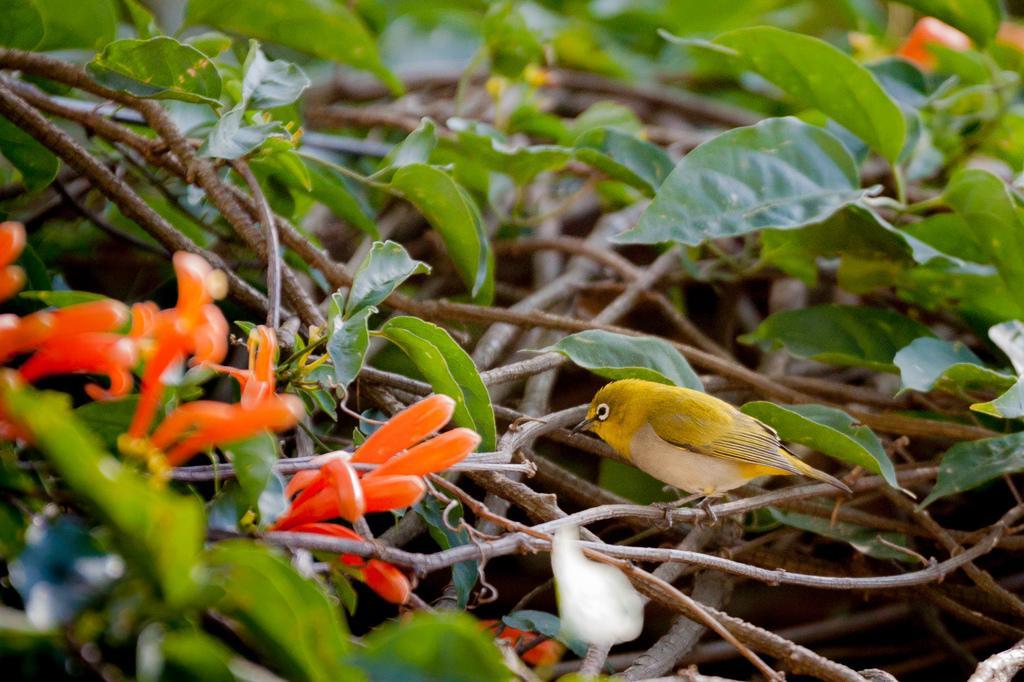Describe this image in one or two sentences. In the image we can see some plants and flowers, on the plants there is a bird. 